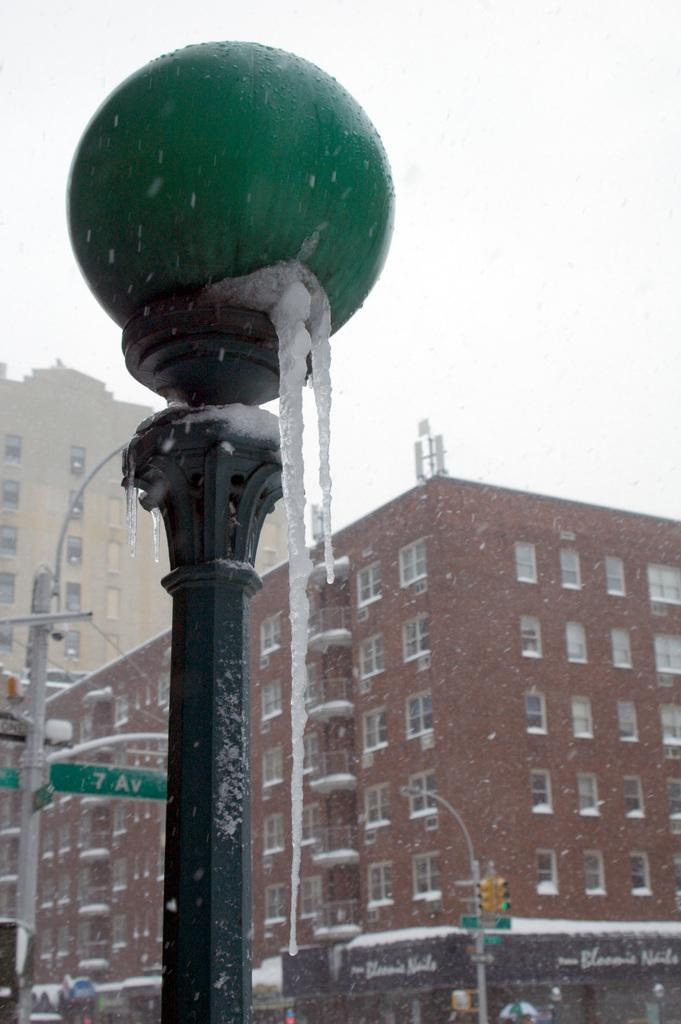What type of structure can be seen in the image? There is a street pole in the image. What is attached to the street pole? There is a street light attached to the street pole. What else can be seen in the image besides the street pole and light? There are buildings, traffic signals, and stalls visible in the image. What is visible in the background of the image? The sky is visible in the image. Can you see any stamps being used at the stalls in the image? There is no mention of stamps or any stamp-related activity in the image. The image features stalls, but their purpose or the items being sold are not specified. 